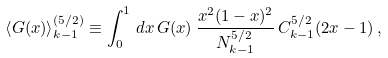<formula> <loc_0><loc_0><loc_500><loc_500>\left < G ( x ) \right > _ { k - 1 } ^ { ( 5 / 2 ) } \equiv \int _ { 0 } ^ { 1 } \, d x \, G ( x ) \, \frac { x ^ { 2 } ( 1 - x ) ^ { 2 } } { N _ { k - 1 } ^ { 5 / 2 } } \, C _ { k - 1 } ^ { 5 / 2 } ( 2 x - 1 ) \, ,</formula> 